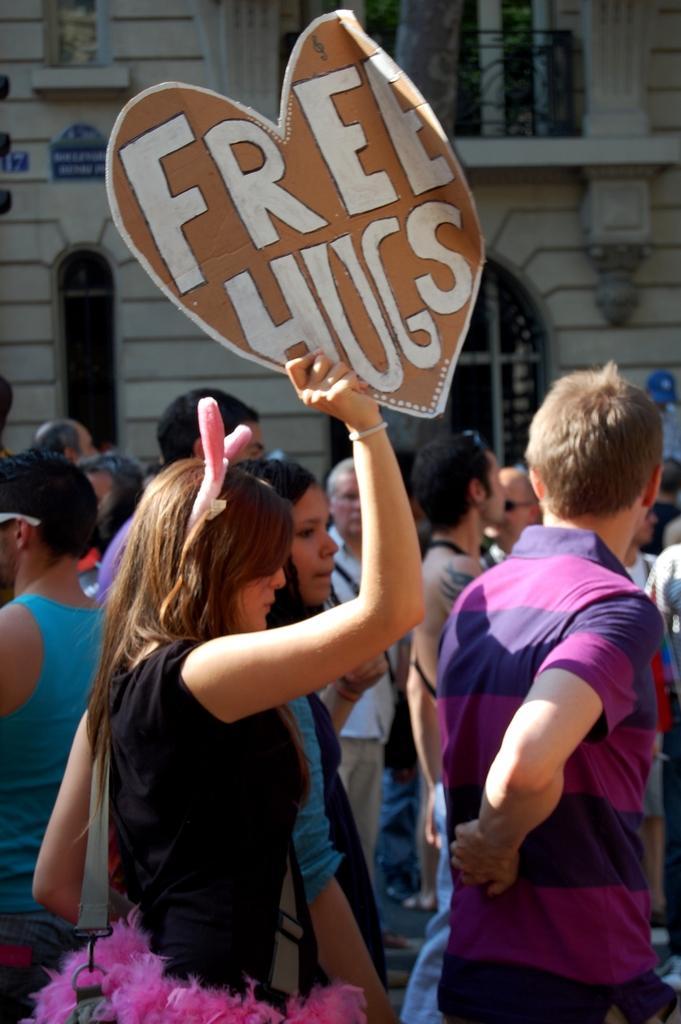How would you summarize this image in a sentence or two? In this picture we can see a group of people where a woman holding a banner with her hand and in the background we can see a building with windows. 